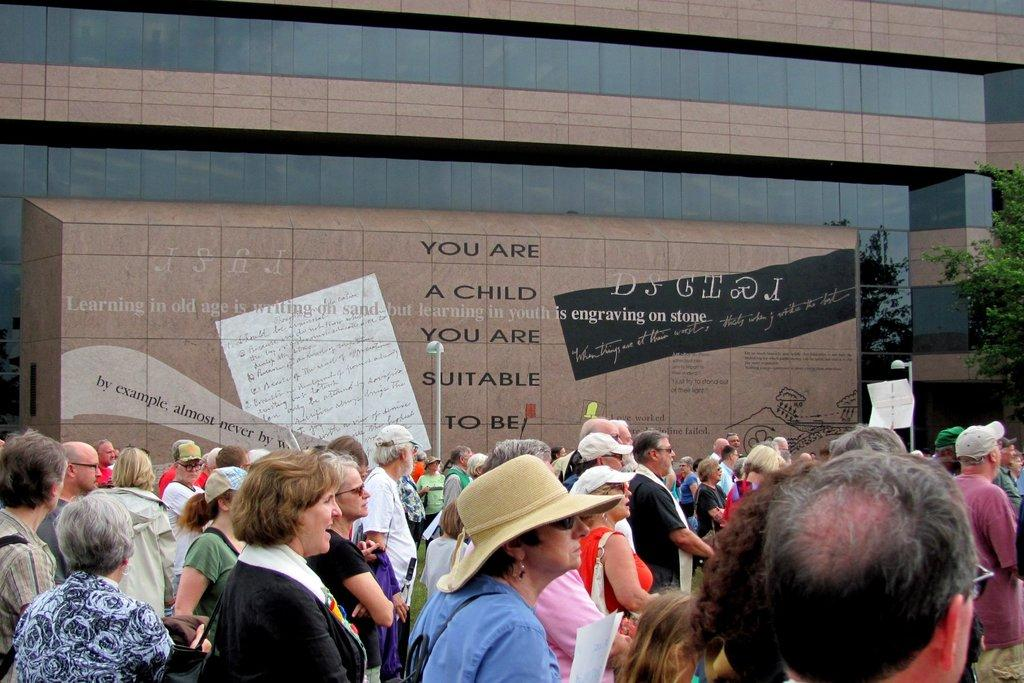How many people are in the group that is visible in the image? There is a group of people in the image, but the exact number is not specified. What accessories are some people in the group wearing? Some people in the group are wearing caps and spectacles. What can be seen in the background of the image? There is a building, poles, and a tree in the background of the image. What type of pain is being experienced by the people in the image? There is no indication in the image that the people are experiencing any pain. 